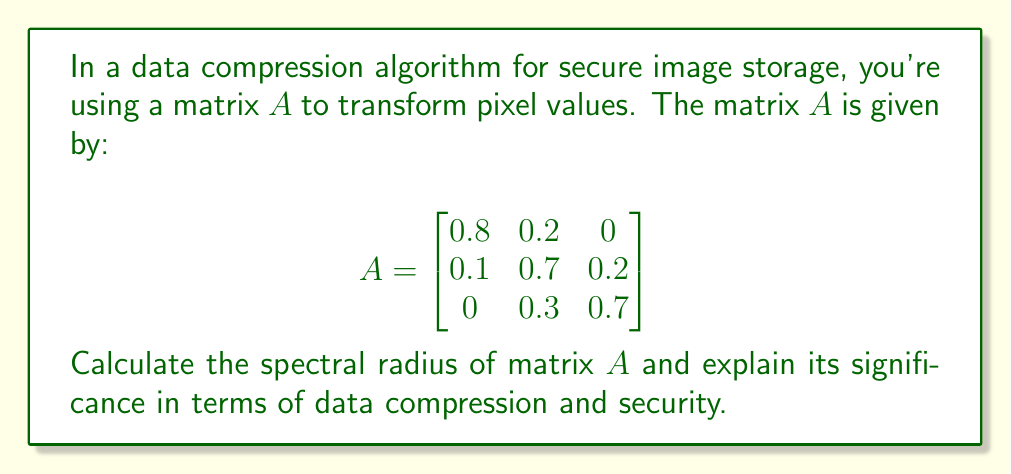Can you solve this math problem? To find the spectral radius of matrix $A$, we need to follow these steps:

1. Find the characteristic polynomial of $A$:
   $det(A - \lambda I) = 0$
   
   $$\begin{vmatrix}
   0.8-\lambda & 0.2 & 0 \\
   0.1 & 0.7-\lambda & 0.2 \\
   0 & 0.3 & 0.7-\lambda
   \end{vmatrix} = 0$$

2. Expand the determinant:
   $(0.8-\lambda)[(0.7-\lambda)(0.7-\lambda) - 0.06] - 0.2[0.1(0.7-\lambda) - 0(0.3)] = 0$
   
   $\lambda^3 - 2.2\lambda^2 + 1.57\lambda - 0.364 = 0$

3. Solve for the eigenvalues. Using a numerical method or computer algebra system, we get:
   $\lambda_1 \approx 1$
   $\lambda_2 \approx 0.6$
   $\lambda_3 \approx 0.6$

4. The spectral radius $\rho(A)$ is the maximum absolute value of the eigenvalues:
   $\rho(A) = max(|\lambda_1|, |\lambda_2|, |\lambda_3|) = 1$

Significance in data compression and security:

1. Compression: The spectral radius being 1 indicates that repeated application of this transformation (as in iterative compression algorithms) will not cause the data to shrink to zero or explode to infinity. This property is crucial for maintaining data integrity during compression.

2. Security: From a security perspective, the spectral radius of 1 suggests that the transformation is non-expanding, which helps preserve the overall structure of the data. This can be beneficial for maintaining the confidentiality of the original image, as it doesn't amplify small differences that could be exploited in statistical attacks.

3. Stability: The spectral radius of 1 implies that the transformation is on the border of stability. In practice, this means that small numerical errors won't grow exponentially when the transformation is applied repeatedly, which is important for maintaining the accuracy of the compressed data over multiple compression-decompression cycles.

4. Reversibility: With a spectral radius of 1, there's a possibility that the transformation is reversible or close to reversible, which is crucial for lossless or near-lossless compression techniques. This property ensures that the original data can be recovered with high fidelity, which is often a security requirement in sensitive applications.
Answer: The spectral radius of matrix $A$ is 1. 